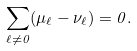Convert formula to latex. <formula><loc_0><loc_0><loc_500><loc_500>\sum _ { \ell \neq 0 } ( \mu _ { \ell } - \nu _ { \ell } ) = 0 .</formula> 